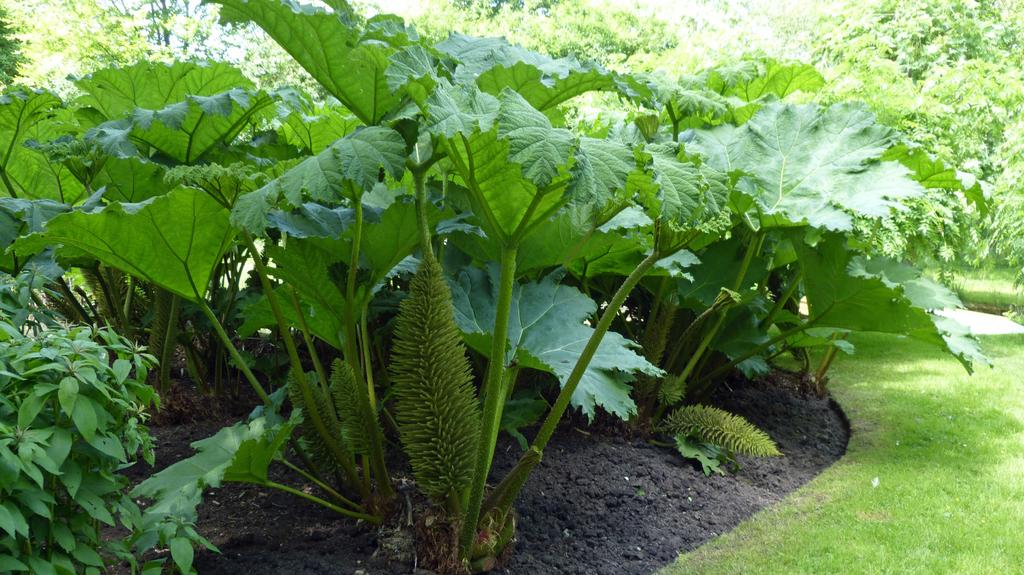What type of vegetation can be seen in the image? There are plants in the image. What can be found at the bottom of the image? There is grass and soil at the bottom of the image. What is visible in the background of the image? There are trees in the background of the image. How many women are present in the image? There are no women present in the image; it features plants, grass, soil, and trees. What do the plants in the image believe about the existence of deer? Plants do not have beliefs, and there are no deer present in the image. 